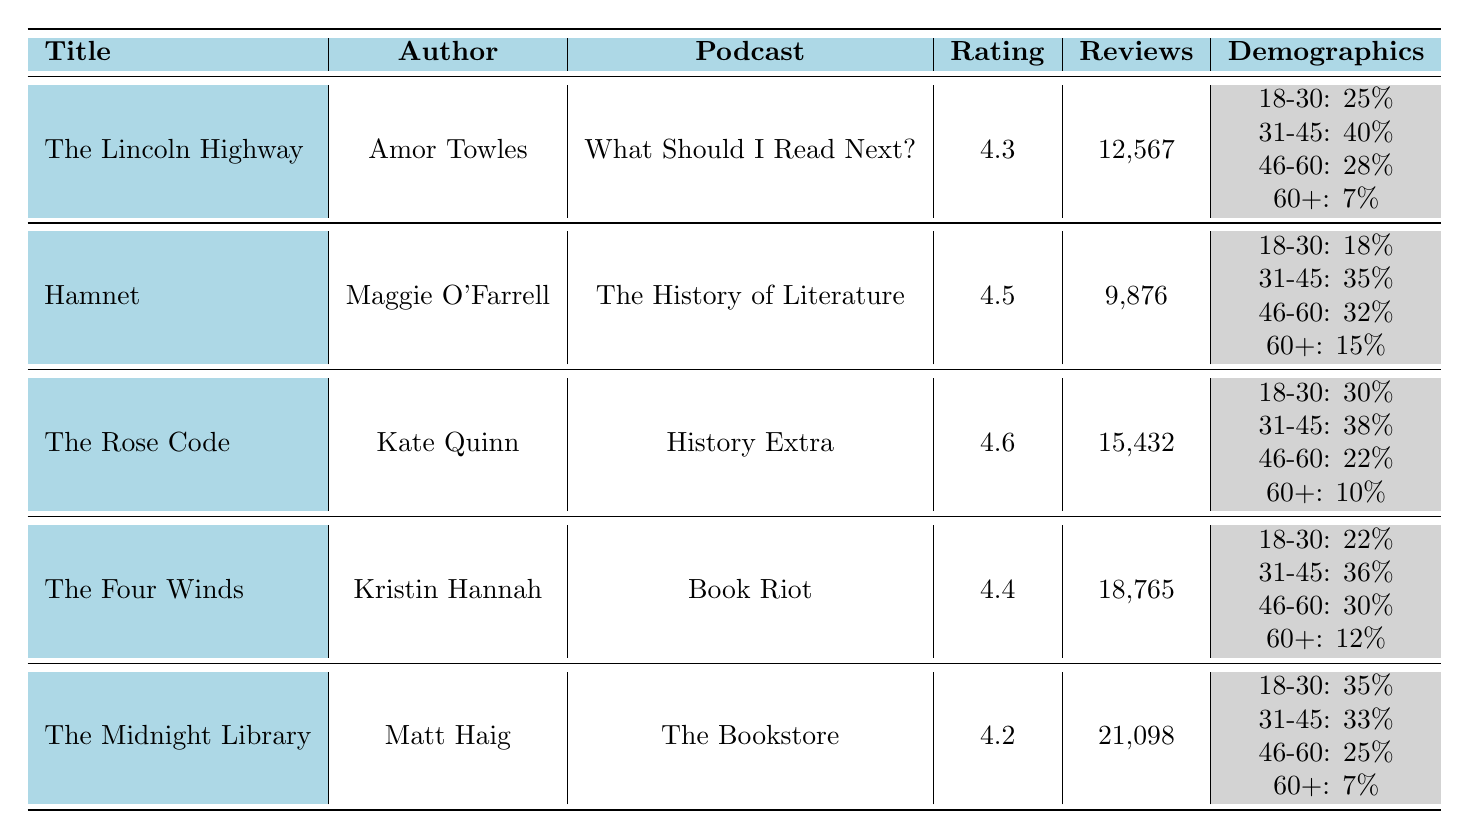What is the title of the audiobook with the highest average rating? Looking at the table, "The Rose Code" by Kate Quinn has the highest average rating of 4.6.
Answer: The Rose Code How many total reviews did "The Four Winds" receive? The table shows that "The Four Winds" received a total of 18,765 reviews.
Answer: 18,765 Which audiobook has the least number of total reviews? By comparing the total reviews for each audiobook, "Hamnet" has the least at 9,876 reviews.
Answer: Hamnet What is the average rating of audiobooks recommended by "What Should I Read Next?" and "The History of Literature"? The average rating for "The Lincoln Highway" is 4.3 and for "Hamnet" is 4.5. Calculating the average: (4.3 + 4.5) / 2 = 4.4.
Answer: 4.4 Are there more listeners aged 31-45 for "The Midnight Library" or "The Rose Code"? "The Midnight Library" has 33% of listeners aged 31-45 while "The Rose Code" has 38%. Since 38% is greater than 33%, "The Rose Code" has more listeners in this age group.
Answer: The Rose Code What percentage of listeners aged 18-30 prefer "The Four Winds"? The table states that 22% of listeners aged 18-30 prefer "The Four Winds."
Answer: 22% How many listeners aged 60+ listened to "Hamnet"? "Hamnet" has 15% listeners aged 60+. To find the number of listeners, we need the total reviews, which is 9,876; so, 15% of that is 0.15 * 9876 = 1,481.4. Since we can't have a fraction of a listener, we round it to 1,481.
Answer: Approximately 1,481 Which audiobook has the highest percentage of listeners aged 18-30? "The Midnight Library" has the highest percentage of listeners aged 18-30 at 35%.
Answer: The Midnight Library What differentiates the listener demographics of "The Lincoln Highway" and "The Four Winds" for the age group 31-45? "The Lincoln Highway" has 40% of listeners aged 31-45, whereas "The Four Winds" has 36%. The difference between these two percentages is 4%, indicating "The Lincoln Highway" attracts a higher proportion of this age group.
Answer: 4% Is "The Rose Code" rated higher than "The Midnight Library"? The Rose Code has an average rating of 4.6, while The Midnight Library has a rating of 4.2. Since 4.6 is greater than 4.2, "The Rose Code" is rated higher.
Answer: Yes 